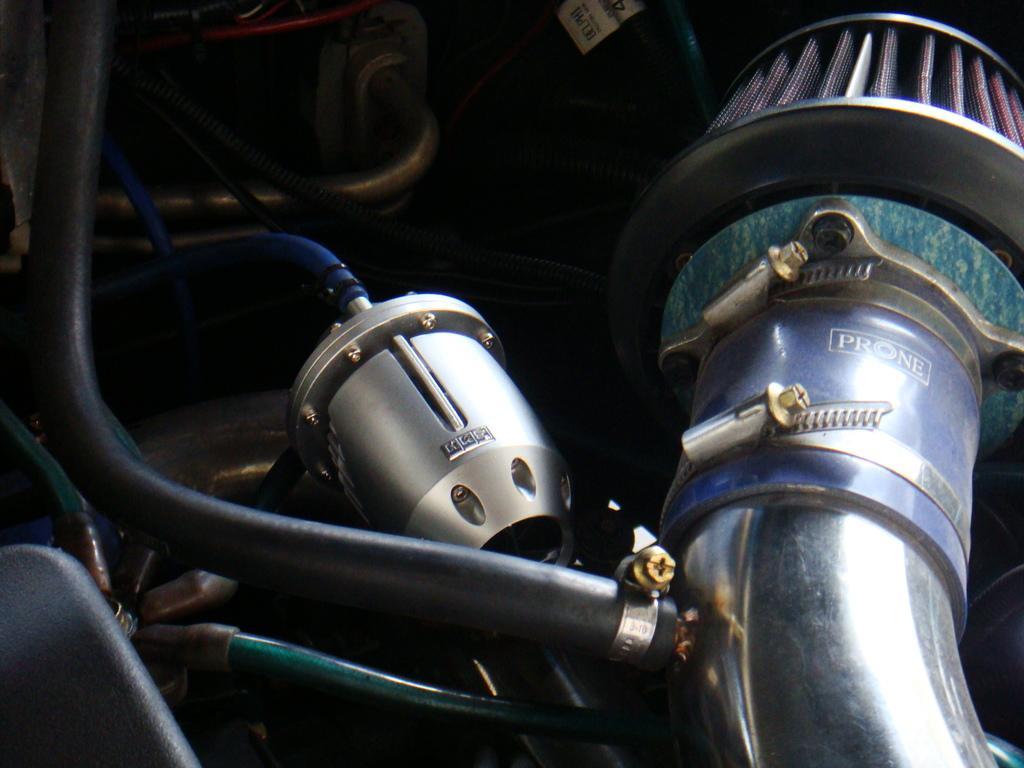Describe this image in one or two sentences. In this image, we can see an engine, rods and pipes. 